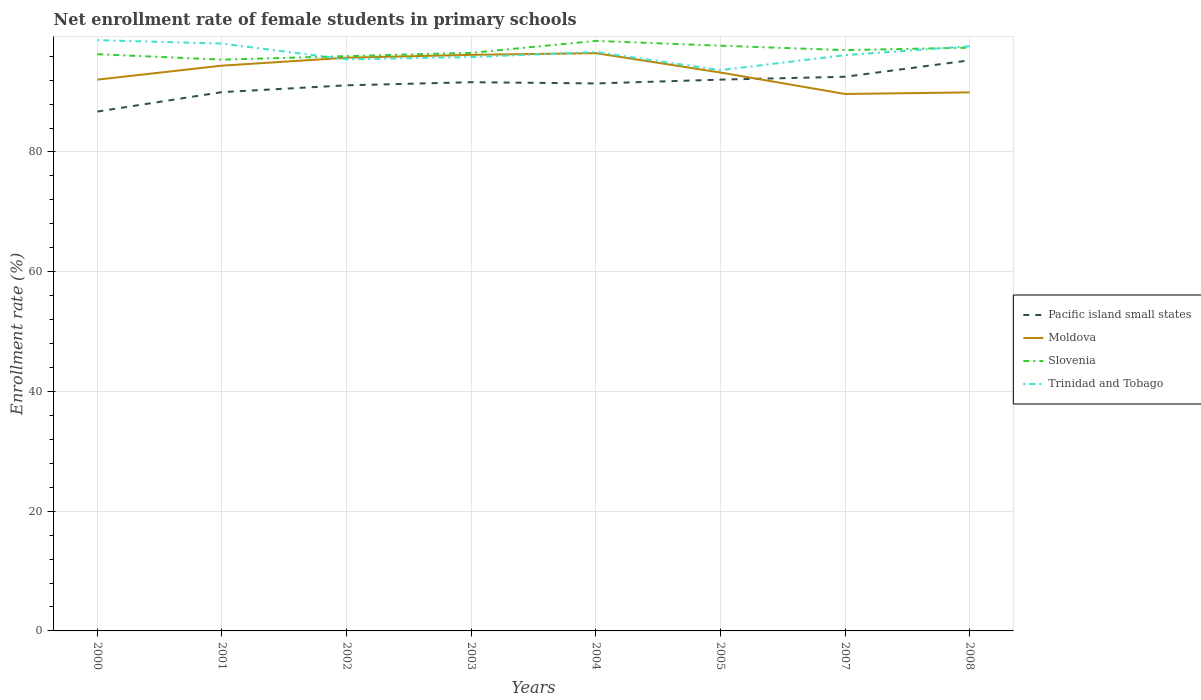How many different coloured lines are there?
Give a very brief answer. 4. Does the line corresponding to Slovenia intersect with the line corresponding to Trinidad and Tobago?
Give a very brief answer. Yes. Is the number of lines equal to the number of legend labels?
Your answer should be compact. Yes. Across all years, what is the maximum net enrollment rate of female students in primary schools in Trinidad and Tobago?
Keep it short and to the point. 93.67. In which year was the net enrollment rate of female students in primary schools in Trinidad and Tobago maximum?
Make the answer very short. 2005. What is the total net enrollment rate of female students in primary schools in Trinidad and Tobago in the graph?
Ensure brevity in your answer.  -2.19. What is the difference between the highest and the second highest net enrollment rate of female students in primary schools in Slovenia?
Offer a terse response. 3.13. What is the difference between the highest and the lowest net enrollment rate of female students in primary schools in Pacific island small states?
Your answer should be compact. 5. Is the net enrollment rate of female students in primary schools in Pacific island small states strictly greater than the net enrollment rate of female students in primary schools in Moldova over the years?
Provide a succinct answer. No. How many lines are there?
Ensure brevity in your answer.  4. How many years are there in the graph?
Ensure brevity in your answer.  8. Are the values on the major ticks of Y-axis written in scientific E-notation?
Provide a succinct answer. No. Does the graph contain any zero values?
Give a very brief answer. No. Does the graph contain grids?
Your answer should be compact. Yes. What is the title of the graph?
Provide a short and direct response. Net enrollment rate of female students in primary schools. What is the label or title of the Y-axis?
Provide a short and direct response. Enrollment rate (%). What is the Enrollment rate (%) in Pacific island small states in 2000?
Your answer should be very brief. 86.75. What is the Enrollment rate (%) of Moldova in 2000?
Offer a very short reply. 92.08. What is the Enrollment rate (%) in Slovenia in 2000?
Offer a very short reply. 96.33. What is the Enrollment rate (%) in Trinidad and Tobago in 2000?
Ensure brevity in your answer.  98.68. What is the Enrollment rate (%) in Pacific island small states in 2001?
Your answer should be compact. 90. What is the Enrollment rate (%) of Moldova in 2001?
Your answer should be compact. 94.42. What is the Enrollment rate (%) in Slovenia in 2001?
Give a very brief answer. 95.42. What is the Enrollment rate (%) in Trinidad and Tobago in 2001?
Ensure brevity in your answer.  98.1. What is the Enrollment rate (%) of Pacific island small states in 2002?
Provide a succinct answer. 91.13. What is the Enrollment rate (%) in Moldova in 2002?
Provide a succinct answer. 95.74. What is the Enrollment rate (%) in Slovenia in 2002?
Ensure brevity in your answer.  96.01. What is the Enrollment rate (%) of Trinidad and Tobago in 2002?
Offer a very short reply. 95.48. What is the Enrollment rate (%) of Pacific island small states in 2003?
Ensure brevity in your answer.  91.65. What is the Enrollment rate (%) of Moldova in 2003?
Offer a terse response. 96.23. What is the Enrollment rate (%) of Slovenia in 2003?
Give a very brief answer. 96.56. What is the Enrollment rate (%) in Trinidad and Tobago in 2003?
Your response must be concise. 95.85. What is the Enrollment rate (%) of Pacific island small states in 2004?
Offer a terse response. 91.45. What is the Enrollment rate (%) of Moldova in 2004?
Your response must be concise. 96.51. What is the Enrollment rate (%) in Slovenia in 2004?
Your answer should be very brief. 98.55. What is the Enrollment rate (%) of Trinidad and Tobago in 2004?
Keep it short and to the point. 96.7. What is the Enrollment rate (%) of Pacific island small states in 2005?
Offer a very short reply. 92.08. What is the Enrollment rate (%) of Moldova in 2005?
Provide a short and direct response. 93.27. What is the Enrollment rate (%) in Slovenia in 2005?
Your answer should be compact. 97.75. What is the Enrollment rate (%) of Trinidad and Tobago in 2005?
Your answer should be compact. 93.67. What is the Enrollment rate (%) in Pacific island small states in 2007?
Your response must be concise. 92.56. What is the Enrollment rate (%) in Moldova in 2007?
Your response must be concise. 89.69. What is the Enrollment rate (%) in Slovenia in 2007?
Your answer should be compact. 97.01. What is the Enrollment rate (%) in Trinidad and Tobago in 2007?
Provide a succinct answer. 96.17. What is the Enrollment rate (%) of Pacific island small states in 2008?
Make the answer very short. 95.31. What is the Enrollment rate (%) in Moldova in 2008?
Your response must be concise. 89.96. What is the Enrollment rate (%) of Slovenia in 2008?
Provide a succinct answer. 97.42. What is the Enrollment rate (%) in Trinidad and Tobago in 2008?
Your answer should be compact. 97.66. Across all years, what is the maximum Enrollment rate (%) of Pacific island small states?
Provide a succinct answer. 95.31. Across all years, what is the maximum Enrollment rate (%) in Moldova?
Give a very brief answer. 96.51. Across all years, what is the maximum Enrollment rate (%) in Slovenia?
Provide a short and direct response. 98.55. Across all years, what is the maximum Enrollment rate (%) in Trinidad and Tobago?
Your answer should be very brief. 98.68. Across all years, what is the minimum Enrollment rate (%) in Pacific island small states?
Give a very brief answer. 86.75. Across all years, what is the minimum Enrollment rate (%) of Moldova?
Your answer should be very brief. 89.69. Across all years, what is the minimum Enrollment rate (%) of Slovenia?
Your answer should be compact. 95.42. Across all years, what is the minimum Enrollment rate (%) in Trinidad and Tobago?
Provide a succinct answer. 93.67. What is the total Enrollment rate (%) in Pacific island small states in the graph?
Your response must be concise. 730.94. What is the total Enrollment rate (%) in Moldova in the graph?
Keep it short and to the point. 747.89. What is the total Enrollment rate (%) in Slovenia in the graph?
Keep it short and to the point. 775.06. What is the total Enrollment rate (%) of Trinidad and Tobago in the graph?
Provide a succinct answer. 772.32. What is the difference between the Enrollment rate (%) of Pacific island small states in 2000 and that in 2001?
Make the answer very short. -3.25. What is the difference between the Enrollment rate (%) in Moldova in 2000 and that in 2001?
Keep it short and to the point. -2.34. What is the difference between the Enrollment rate (%) in Slovenia in 2000 and that in 2001?
Your response must be concise. 0.91. What is the difference between the Enrollment rate (%) in Trinidad and Tobago in 2000 and that in 2001?
Keep it short and to the point. 0.58. What is the difference between the Enrollment rate (%) of Pacific island small states in 2000 and that in 2002?
Give a very brief answer. -4.38. What is the difference between the Enrollment rate (%) in Moldova in 2000 and that in 2002?
Make the answer very short. -3.66. What is the difference between the Enrollment rate (%) in Slovenia in 2000 and that in 2002?
Your answer should be compact. 0.32. What is the difference between the Enrollment rate (%) in Trinidad and Tobago in 2000 and that in 2002?
Your response must be concise. 3.2. What is the difference between the Enrollment rate (%) of Pacific island small states in 2000 and that in 2003?
Your answer should be compact. -4.9. What is the difference between the Enrollment rate (%) of Moldova in 2000 and that in 2003?
Make the answer very short. -4.14. What is the difference between the Enrollment rate (%) in Slovenia in 2000 and that in 2003?
Ensure brevity in your answer.  -0.22. What is the difference between the Enrollment rate (%) of Trinidad and Tobago in 2000 and that in 2003?
Give a very brief answer. 2.83. What is the difference between the Enrollment rate (%) of Pacific island small states in 2000 and that in 2004?
Your response must be concise. -4.7. What is the difference between the Enrollment rate (%) of Moldova in 2000 and that in 2004?
Provide a succinct answer. -4.42. What is the difference between the Enrollment rate (%) in Slovenia in 2000 and that in 2004?
Provide a short and direct response. -2.22. What is the difference between the Enrollment rate (%) in Trinidad and Tobago in 2000 and that in 2004?
Give a very brief answer. 1.98. What is the difference between the Enrollment rate (%) of Pacific island small states in 2000 and that in 2005?
Offer a terse response. -5.33. What is the difference between the Enrollment rate (%) of Moldova in 2000 and that in 2005?
Give a very brief answer. -1.19. What is the difference between the Enrollment rate (%) of Slovenia in 2000 and that in 2005?
Offer a very short reply. -1.42. What is the difference between the Enrollment rate (%) of Trinidad and Tobago in 2000 and that in 2005?
Make the answer very short. 5.01. What is the difference between the Enrollment rate (%) in Pacific island small states in 2000 and that in 2007?
Offer a very short reply. -5.81. What is the difference between the Enrollment rate (%) of Moldova in 2000 and that in 2007?
Provide a succinct answer. 2.4. What is the difference between the Enrollment rate (%) of Slovenia in 2000 and that in 2007?
Ensure brevity in your answer.  -0.68. What is the difference between the Enrollment rate (%) of Trinidad and Tobago in 2000 and that in 2007?
Your answer should be very brief. 2.51. What is the difference between the Enrollment rate (%) of Pacific island small states in 2000 and that in 2008?
Provide a succinct answer. -8.56. What is the difference between the Enrollment rate (%) in Moldova in 2000 and that in 2008?
Provide a short and direct response. 2.13. What is the difference between the Enrollment rate (%) in Slovenia in 2000 and that in 2008?
Offer a very short reply. -1.09. What is the difference between the Enrollment rate (%) in Trinidad and Tobago in 2000 and that in 2008?
Give a very brief answer. 1.02. What is the difference between the Enrollment rate (%) of Pacific island small states in 2001 and that in 2002?
Your answer should be very brief. -1.14. What is the difference between the Enrollment rate (%) of Moldova in 2001 and that in 2002?
Make the answer very short. -1.32. What is the difference between the Enrollment rate (%) in Slovenia in 2001 and that in 2002?
Offer a very short reply. -0.59. What is the difference between the Enrollment rate (%) in Trinidad and Tobago in 2001 and that in 2002?
Offer a very short reply. 2.63. What is the difference between the Enrollment rate (%) in Pacific island small states in 2001 and that in 2003?
Give a very brief answer. -1.66. What is the difference between the Enrollment rate (%) in Moldova in 2001 and that in 2003?
Provide a short and direct response. -1.81. What is the difference between the Enrollment rate (%) in Slovenia in 2001 and that in 2003?
Provide a short and direct response. -1.13. What is the difference between the Enrollment rate (%) in Trinidad and Tobago in 2001 and that in 2003?
Make the answer very short. 2.25. What is the difference between the Enrollment rate (%) in Pacific island small states in 2001 and that in 2004?
Keep it short and to the point. -1.45. What is the difference between the Enrollment rate (%) in Moldova in 2001 and that in 2004?
Your response must be concise. -2.09. What is the difference between the Enrollment rate (%) in Slovenia in 2001 and that in 2004?
Offer a terse response. -3.13. What is the difference between the Enrollment rate (%) of Trinidad and Tobago in 2001 and that in 2004?
Keep it short and to the point. 1.4. What is the difference between the Enrollment rate (%) in Pacific island small states in 2001 and that in 2005?
Ensure brevity in your answer.  -2.09. What is the difference between the Enrollment rate (%) of Moldova in 2001 and that in 2005?
Make the answer very short. 1.15. What is the difference between the Enrollment rate (%) of Slovenia in 2001 and that in 2005?
Your answer should be compact. -2.33. What is the difference between the Enrollment rate (%) in Trinidad and Tobago in 2001 and that in 2005?
Your response must be concise. 4.43. What is the difference between the Enrollment rate (%) of Pacific island small states in 2001 and that in 2007?
Your response must be concise. -2.57. What is the difference between the Enrollment rate (%) in Moldova in 2001 and that in 2007?
Provide a succinct answer. 4.73. What is the difference between the Enrollment rate (%) of Slovenia in 2001 and that in 2007?
Keep it short and to the point. -1.59. What is the difference between the Enrollment rate (%) in Trinidad and Tobago in 2001 and that in 2007?
Give a very brief answer. 1.93. What is the difference between the Enrollment rate (%) of Pacific island small states in 2001 and that in 2008?
Offer a very short reply. -5.31. What is the difference between the Enrollment rate (%) of Moldova in 2001 and that in 2008?
Keep it short and to the point. 4.46. What is the difference between the Enrollment rate (%) of Slovenia in 2001 and that in 2008?
Your answer should be compact. -2. What is the difference between the Enrollment rate (%) of Trinidad and Tobago in 2001 and that in 2008?
Make the answer very short. 0.44. What is the difference between the Enrollment rate (%) in Pacific island small states in 2002 and that in 2003?
Your answer should be compact. -0.52. What is the difference between the Enrollment rate (%) of Moldova in 2002 and that in 2003?
Your answer should be very brief. -0.48. What is the difference between the Enrollment rate (%) of Slovenia in 2002 and that in 2003?
Provide a short and direct response. -0.55. What is the difference between the Enrollment rate (%) of Trinidad and Tobago in 2002 and that in 2003?
Make the answer very short. -0.38. What is the difference between the Enrollment rate (%) in Pacific island small states in 2002 and that in 2004?
Ensure brevity in your answer.  -0.31. What is the difference between the Enrollment rate (%) of Moldova in 2002 and that in 2004?
Provide a short and direct response. -0.77. What is the difference between the Enrollment rate (%) in Slovenia in 2002 and that in 2004?
Give a very brief answer. -2.54. What is the difference between the Enrollment rate (%) in Trinidad and Tobago in 2002 and that in 2004?
Offer a terse response. -1.22. What is the difference between the Enrollment rate (%) of Pacific island small states in 2002 and that in 2005?
Offer a very short reply. -0.95. What is the difference between the Enrollment rate (%) in Moldova in 2002 and that in 2005?
Keep it short and to the point. 2.47. What is the difference between the Enrollment rate (%) of Slovenia in 2002 and that in 2005?
Provide a succinct answer. -1.74. What is the difference between the Enrollment rate (%) of Trinidad and Tobago in 2002 and that in 2005?
Offer a terse response. 1.81. What is the difference between the Enrollment rate (%) of Pacific island small states in 2002 and that in 2007?
Ensure brevity in your answer.  -1.43. What is the difference between the Enrollment rate (%) in Moldova in 2002 and that in 2007?
Offer a very short reply. 6.06. What is the difference between the Enrollment rate (%) of Slovenia in 2002 and that in 2007?
Provide a short and direct response. -1. What is the difference between the Enrollment rate (%) in Trinidad and Tobago in 2002 and that in 2007?
Your answer should be very brief. -0.7. What is the difference between the Enrollment rate (%) in Pacific island small states in 2002 and that in 2008?
Provide a succinct answer. -4.18. What is the difference between the Enrollment rate (%) of Moldova in 2002 and that in 2008?
Provide a succinct answer. 5.78. What is the difference between the Enrollment rate (%) of Slovenia in 2002 and that in 2008?
Give a very brief answer. -1.41. What is the difference between the Enrollment rate (%) of Trinidad and Tobago in 2002 and that in 2008?
Offer a terse response. -2.19. What is the difference between the Enrollment rate (%) in Pacific island small states in 2003 and that in 2004?
Provide a succinct answer. 0.21. What is the difference between the Enrollment rate (%) of Moldova in 2003 and that in 2004?
Keep it short and to the point. -0.28. What is the difference between the Enrollment rate (%) of Slovenia in 2003 and that in 2004?
Ensure brevity in your answer.  -1.99. What is the difference between the Enrollment rate (%) in Trinidad and Tobago in 2003 and that in 2004?
Provide a short and direct response. -0.85. What is the difference between the Enrollment rate (%) of Pacific island small states in 2003 and that in 2005?
Your answer should be compact. -0.43. What is the difference between the Enrollment rate (%) in Moldova in 2003 and that in 2005?
Provide a short and direct response. 2.95. What is the difference between the Enrollment rate (%) of Slovenia in 2003 and that in 2005?
Give a very brief answer. -1.19. What is the difference between the Enrollment rate (%) of Trinidad and Tobago in 2003 and that in 2005?
Offer a terse response. 2.18. What is the difference between the Enrollment rate (%) in Pacific island small states in 2003 and that in 2007?
Provide a short and direct response. -0.91. What is the difference between the Enrollment rate (%) of Moldova in 2003 and that in 2007?
Keep it short and to the point. 6.54. What is the difference between the Enrollment rate (%) of Slovenia in 2003 and that in 2007?
Ensure brevity in your answer.  -0.45. What is the difference between the Enrollment rate (%) of Trinidad and Tobago in 2003 and that in 2007?
Ensure brevity in your answer.  -0.32. What is the difference between the Enrollment rate (%) of Pacific island small states in 2003 and that in 2008?
Offer a very short reply. -3.66. What is the difference between the Enrollment rate (%) in Moldova in 2003 and that in 2008?
Your response must be concise. 6.27. What is the difference between the Enrollment rate (%) of Slovenia in 2003 and that in 2008?
Provide a succinct answer. -0.87. What is the difference between the Enrollment rate (%) of Trinidad and Tobago in 2003 and that in 2008?
Make the answer very short. -1.81. What is the difference between the Enrollment rate (%) in Pacific island small states in 2004 and that in 2005?
Your answer should be very brief. -0.64. What is the difference between the Enrollment rate (%) in Moldova in 2004 and that in 2005?
Provide a succinct answer. 3.23. What is the difference between the Enrollment rate (%) in Slovenia in 2004 and that in 2005?
Offer a very short reply. 0.8. What is the difference between the Enrollment rate (%) in Trinidad and Tobago in 2004 and that in 2005?
Provide a short and direct response. 3.03. What is the difference between the Enrollment rate (%) of Pacific island small states in 2004 and that in 2007?
Ensure brevity in your answer.  -1.12. What is the difference between the Enrollment rate (%) in Moldova in 2004 and that in 2007?
Give a very brief answer. 6.82. What is the difference between the Enrollment rate (%) of Slovenia in 2004 and that in 2007?
Your answer should be very brief. 1.54. What is the difference between the Enrollment rate (%) in Trinidad and Tobago in 2004 and that in 2007?
Ensure brevity in your answer.  0.53. What is the difference between the Enrollment rate (%) of Pacific island small states in 2004 and that in 2008?
Your answer should be very brief. -3.86. What is the difference between the Enrollment rate (%) in Moldova in 2004 and that in 2008?
Keep it short and to the point. 6.55. What is the difference between the Enrollment rate (%) of Slovenia in 2004 and that in 2008?
Provide a succinct answer. 1.13. What is the difference between the Enrollment rate (%) of Trinidad and Tobago in 2004 and that in 2008?
Offer a very short reply. -0.96. What is the difference between the Enrollment rate (%) of Pacific island small states in 2005 and that in 2007?
Provide a short and direct response. -0.48. What is the difference between the Enrollment rate (%) in Moldova in 2005 and that in 2007?
Your answer should be compact. 3.59. What is the difference between the Enrollment rate (%) of Slovenia in 2005 and that in 2007?
Your answer should be compact. 0.74. What is the difference between the Enrollment rate (%) in Trinidad and Tobago in 2005 and that in 2007?
Provide a succinct answer. -2.5. What is the difference between the Enrollment rate (%) of Pacific island small states in 2005 and that in 2008?
Offer a very short reply. -3.23. What is the difference between the Enrollment rate (%) of Moldova in 2005 and that in 2008?
Offer a terse response. 3.32. What is the difference between the Enrollment rate (%) in Slovenia in 2005 and that in 2008?
Your response must be concise. 0.33. What is the difference between the Enrollment rate (%) of Trinidad and Tobago in 2005 and that in 2008?
Provide a succinct answer. -3.99. What is the difference between the Enrollment rate (%) in Pacific island small states in 2007 and that in 2008?
Give a very brief answer. -2.75. What is the difference between the Enrollment rate (%) in Moldova in 2007 and that in 2008?
Your answer should be compact. -0.27. What is the difference between the Enrollment rate (%) in Slovenia in 2007 and that in 2008?
Give a very brief answer. -0.41. What is the difference between the Enrollment rate (%) in Trinidad and Tobago in 2007 and that in 2008?
Offer a terse response. -1.49. What is the difference between the Enrollment rate (%) in Pacific island small states in 2000 and the Enrollment rate (%) in Moldova in 2001?
Provide a succinct answer. -7.67. What is the difference between the Enrollment rate (%) of Pacific island small states in 2000 and the Enrollment rate (%) of Slovenia in 2001?
Your response must be concise. -8.67. What is the difference between the Enrollment rate (%) of Pacific island small states in 2000 and the Enrollment rate (%) of Trinidad and Tobago in 2001?
Your answer should be very brief. -11.35. What is the difference between the Enrollment rate (%) in Moldova in 2000 and the Enrollment rate (%) in Slovenia in 2001?
Your answer should be very brief. -3.34. What is the difference between the Enrollment rate (%) of Moldova in 2000 and the Enrollment rate (%) of Trinidad and Tobago in 2001?
Make the answer very short. -6.02. What is the difference between the Enrollment rate (%) of Slovenia in 2000 and the Enrollment rate (%) of Trinidad and Tobago in 2001?
Give a very brief answer. -1.77. What is the difference between the Enrollment rate (%) of Pacific island small states in 2000 and the Enrollment rate (%) of Moldova in 2002?
Make the answer very short. -8.99. What is the difference between the Enrollment rate (%) in Pacific island small states in 2000 and the Enrollment rate (%) in Slovenia in 2002?
Ensure brevity in your answer.  -9.26. What is the difference between the Enrollment rate (%) in Pacific island small states in 2000 and the Enrollment rate (%) in Trinidad and Tobago in 2002?
Offer a very short reply. -8.72. What is the difference between the Enrollment rate (%) of Moldova in 2000 and the Enrollment rate (%) of Slovenia in 2002?
Offer a very short reply. -3.93. What is the difference between the Enrollment rate (%) of Moldova in 2000 and the Enrollment rate (%) of Trinidad and Tobago in 2002?
Provide a succinct answer. -3.39. What is the difference between the Enrollment rate (%) of Slovenia in 2000 and the Enrollment rate (%) of Trinidad and Tobago in 2002?
Your response must be concise. 0.86. What is the difference between the Enrollment rate (%) of Pacific island small states in 2000 and the Enrollment rate (%) of Moldova in 2003?
Provide a short and direct response. -9.47. What is the difference between the Enrollment rate (%) of Pacific island small states in 2000 and the Enrollment rate (%) of Slovenia in 2003?
Provide a succinct answer. -9.81. What is the difference between the Enrollment rate (%) of Pacific island small states in 2000 and the Enrollment rate (%) of Trinidad and Tobago in 2003?
Provide a succinct answer. -9.1. What is the difference between the Enrollment rate (%) in Moldova in 2000 and the Enrollment rate (%) in Slovenia in 2003?
Offer a terse response. -4.47. What is the difference between the Enrollment rate (%) in Moldova in 2000 and the Enrollment rate (%) in Trinidad and Tobago in 2003?
Your response must be concise. -3.77. What is the difference between the Enrollment rate (%) in Slovenia in 2000 and the Enrollment rate (%) in Trinidad and Tobago in 2003?
Your answer should be very brief. 0.48. What is the difference between the Enrollment rate (%) in Pacific island small states in 2000 and the Enrollment rate (%) in Moldova in 2004?
Ensure brevity in your answer.  -9.76. What is the difference between the Enrollment rate (%) of Pacific island small states in 2000 and the Enrollment rate (%) of Slovenia in 2004?
Offer a very short reply. -11.8. What is the difference between the Enrollment rate (%) in Pacific island small states in 2000 and the Enrollment rate (%) in Trinidad and Tobago in 2004?
Provide a succinct answer. -9.95. What is the difference between the Enrollment rate (%) in Moldova in 2000 and the Enrollment rate (%) in Slovenia in 2004?
Provide a succinct answer. -6.47. What is the difference between the Enrollment rate (%) of Moldova in 2000 and the Enrollment rate (%) of Trinidad and Tobago in 2004?
Your answer should be compact. -4.62. What is the difference between the Enrollment rate (%) in Slovenia in 2000 and the Enrollment rate (%) in Trinidad and Tobago in 2004?
Offer a terse response. -0.37. What is the difference between the Enrollment rate (%) in Pacific island small states in 2000 and the Enrollment rate (%) in Moldova in 2005?
Give a very brief answer. -6.52. What is the difference between the Enrollment rate (%) of Pacific island small states in 2000 and the Enrollment rate (%) of Slovenia in 2005?
Offer a very short reply. -11. What is the difference between the Enrollment rate (%) of Pacific island small states in 2000 and the Enrollment rate (%) of Trinidad and Tobago in 2005?
Provide a short and direct response. -6.92. What is the difference between the Enrollment rate (%) in Moldova in 2000 and the Enrollment rate (%) in Slovenia in 2005?
Your response must be concise. -5.67. What is the difference between the Enrollment rate (%) of Moldova in 2000 and the Enrollment rate (%) of Trinidad and Tobago in 2005?
Offer a very short reply. -1.59. What is the difference between the Enrollment rate (%) of Slovenia in 2000 and the Enrollment rate (%) of Trinidad and Tobago in 2005?
Your answer should be compact. 2.66. What is the difference between the Enrollment rate (%) of Pacific island small states in 2000 and the Enrollment rate (%) of Moldova in 2007?
Offer a very short reply. -2.93. What is the difference between the Enrollment rate (%) of Pacific island small states in 2000 and the Enrollment rate (%) of Slovenia in 2007?
Keep it short and to the point. -10.26. What is the difference between the Enrollment rate (%) of Pacific island small states in 2000 and the Enrollment rate (%) of Trinidad and Tobago in 2007?
Ensure brevity in your answer.  -9.42. What is the difference between the Enrollment rate (%) in Moldova in 2000 and the Enrollment rate (%) in Slovenia in 2007?
Make the answer very short. -4.93. What is the difference between the Enrollment rate (%) in Moldova in 2000 and the Enrollment rate (%) in Trinidad and Tobago in 2007?
Your answer should be very brief. -4.09. What is the difference between the Enrollment rate (%) in Slovenia in 2000 and the Enrollment rate (%) in Trinidad and Tobago in 2007?
Make the answer very short. 0.16. What is the difference between the Enrollment rate (%) of Pacific island small states in 2000 and the Enrollment rate (%) of Moldova in 2008?
Keep it short and to the point. -3.21. What is the difference between the Enrollment rate (%) in Pacific island small states in 2000 and the Enrollment rate (%) in Slovenia in 2008?
Provide a short and direct response. -10.67. What is the difference between the Enrollment rate (%) in Pacific island small states in 2000 and the Enrollment rate (%) in Trinidad and Tobago in 2008?
Offer a terse response. -10.91. What is the difference between the Enrollment rate (%) of Moldova in 2000 and the Enrollment rate (%) of Slovenia in 2008?
Your answer should be compact. -5.34. What is the difference between the Enrollment rate (%) of Moldova in 2000 and the Enrollment rate (%) of Trinidad and Tobago in 2008?
Your response must be concise. -5.58. What is the difference between the Enrollment rate (%) of Slovenia in 2000 and the Enrollment rate (%) of Trinidad and Tobago in 2008?
Make the answer very short. -1.33. What is the difference between the Enrollment rate (%) in Pacific island small states in 2001 and the Enrollment rate (%) in Moldova in 2002?
Keep it short and to the point. -5.74. What is the difference between the Enrollment rate (%) of Pacific island small states in 2001 and the Enrollment rate (%) of Slovenia in 2002?
Your answer should be compact. -6.01. What is the difference between the Enrollment rate (%) of Pacific island small states in 2001 and the Enrollment rate (%) of Trinidad and Tobago in 2002?
Offer a terse response. -5.48. What is the difference between the Enrollment rate (%) of Moldova in 2001 and the Enrollment rate (%) of Slovenia in 2002?
Give a very brief answer. -1.59. What is the difference between the Enrollment rate (%) of Moldova in 2001 and the Enrollment rate (%) of Trinidad and Tobago in 2002?
Offer a very short reply. -1.06. What is the difference between the Enrollment rate (%) of Slovenia in 2001 and the Enrollment rate (%) of Trinidad and Tobago in 2002?
Your answer should be very brief. -0.05. What is the difference between the Enrollment rate (%) of Pacific island small states in 2001 and the Enrollment rate (%) of Moldova in 2003?
Your response must be concise. -6.23. What is the difference between the Enrollment rate (%) in Pacific island small states in 2001 and the Enrollment rate (%) in Slovenia in 2003?
Your answer should be compact. -6.56. What is the difference between the Enrollment rate (%) of Pacific island small states in 2001 and the Enrollment rate (%) of Trinidad and Tobago in 2003?
Offer a terse response. -5.86. What is the difference between the Enrollment rate (%) of Moldova in 2001 and the Enrollment rate (%) of Slovenia in 2003?
Ensure brevity in your answer.  -2.14. What is the difference between the Enrollment rate (%) of Moldova in 2001 and the Enrollment rate (%) of Trinidad and Tobago in 2003?
Your answer should be very brief. -1.43. What is the difference between the Enrollment rate (%) of Slovenia in 2001 and the Enrollment rate (%) of Trinidad and Tobago in 2003?
Your answer should be very brief. -0.43. What is the difference between the Enrollment rate (%) in Pacific island small states in 2001 and the Enrollment rate (%) in Moldova in 2004?
Offer a very short reply. -6.51. What is the difference between the Enrollment rate (%) of Pacific island small states in 2001 and the Enrollment rate (%) of Slovenia in 2004?
Your response must be concise. -8.55. What is the difference between the Enrollment rate (%) in Pacific island small states in 2001 and the Enrollment rate (%) in Trinidad and Tobago in 2004?
Ensure brevity in your answer.  -6.7. What is the difference between the Enrollment rate (%) of Moldova in 2001 and the Enrollment rate (%) of Slovenia in 2004?
Ensure brevity in your answer.  -4.13. What is the difference between the Enrollment rate (%) of Moldova in 2001 and the Enrollment rate (%) of Trinidad and Tobago in 2004?
Provide a short and direct response. -2.28. What is the difference between the Enrollment rate (%) of Slovenia in 2001 and the Enrollment rate (%) of Trinidad and Tobago in 2004?
Provide a short and direct response. -1.28. What is the difference between the Enrollment rate (%) in Pacific island small states in 2001 and the Enrollment rate (%) in Moldova in 2005?
Your answer should be very brief. -3.28. What is the difference between the Enrollment rate (%) in Pacific island small states in 2001 and the Enrollment rate (%) in Slovenia in 2005?
Offer a very short reply. -7.75. What is the difference between the Enrollment rate (%) of Pacific island small states in 2001 and the Enrollment rate (%) of Trinidad and Tobago in 2005?
Keep it short and to the point. -3.67. What is the difference between the Enrollment rate (%) in Moldova in 2001 and the Enrollment rate (%) in Slovenia in 2005?
Give a very brief answer. -3.33. What is the difference between the Enrollment rate (%) of Moldova in 2001 and the Enrollment rate (%) of Trinidad and Tobago in 2005?
Give a very brief answer. 0.75. What is the difference between the Enrollment rate (%) in Slovenia in 2001 and the Enrollment rate (%) in Trinidad and Tobago in 2005?
Offer a terse response. 1.75. What is the difference between the Enrollment rate (%) in Pacific island small states in 2001 and the Enrollment rate (%) in Moldova in 2007?
Keep it short and to the point. 0.31. What is the difference between the Enrollment rate (%) in Pacific island small states in 2001 and the Enrollment rate (%) in Slovenia in 2007?
Your response must be concise. -7.01. What is the difference between the Enrollment rate (%) of Pacific island small states in 2001 and the Enrollment rate (%) of Trinidad and Tobago in 2007?
Your answer should be compact. -6.18. What is the difference between the Enrollment rate (%) in Moldova in 2001 and the Enrollment rate (%) in Slovenia in 2007?
Offer a terse response. -2.59. What is the difference between the Enrollment rate (%) of Moldova in 2001 and the Enrollment rate (%) of Trinidad and Tobago in 2007?
Offer a terse response. -1.75. What is the difference between the Enrollment rate (%) of Slovenia in 2001 and the Enrollment rate (%) of Trinidad and Tobago in 2007?
Your answer should be very brief. -0.75. What is the difference between the Enrollment rate (%) in Pacific island small states in 2001 and the Enrollment rate (%) in Moldova in 2008?
Provide a succinct answer. 0.04. What is the difference between the Enrollment rate (%) of Pacific island small states in 2001 and the Enrollment rate (%) of Slovenia in 2008?
Provide a succinct answer. -7.43. What is the difference between the Enrollment rate (%) in Pacific island small states in 2001 and the Enrollment rate (%) in Trinidad and Tobago in 2008?
Ensure brevity in your answer.  -7.66. What is the difference between the Enrollment rate (%) of Moldova in 2001 and the Enrollment rate (%) of Slovenia in 2008?
Keep it short and to the point. -3. What is the difference between the Enrollment rate (%) in Moldova in 2001 and the Enrollment rate (%) in Trinidad and Tobago in 2008?
Keep it short and to the point. -3.24. What is the difference between the Enrollment rate (%) in Slovenia in 2001 and the Enrollment rate (%) in Trinidad and Tobago in 2008?
Give a very brief answer. -2.24. What is the difference between the Enrollment rate (%) in Pacific island small states in 2002 and the Enrollment rate (%) in Moldova in 2003?
Ensure brevity in your answer.  -5.09. What is the difference between the Enrollment rate (%) of Pacific island small states in 2002 and the Enrollment rate (%) of Slovenia in 2003?
Offer a very short reply. -5.42. What is the difference between the Enrollment rate (%) in Pacific island small states in 2002 and the Enrollment rate (%) in Trinidad and Tobago in 2003?
Ensure brevity in your answer.  -4.72. What is the difference between the Enrollment rate (%) in Moldova in 2002 and the Enrollment rate (%) in Slovenia in 2003?
Give a very brief answer. -0.82. What is the difference between the Enrollment rate (%) in Moldova in 2002 and the Enrollment rate (%) in Trinidad and Tobago in 2003?
Your response must be concise. -0.11. What is the difference between the Enrollment rate (%) in Slovenia in 2002 and the Enrollment rate (%) in Trinidad and Tobago in 2003?
Keep it short and to the point. 0.16. What is the difference between the Enrollment rate (%) in Pacific island small states in 2002 and the Enrollment rate (%) in Moldova in 2004?
Your answer should be very brief. -5.37. What is the difference between the Enrollment rate (%) in Pacific island small states in 2002 and the Enrollment rate (%) in Slovenia in 2004?
Offer a very short reply. -7.42. What is the difference between the Enrollment rate (%) in Pacific island small states in 2002 and the Enrollment rate (%) in Trinidad and Tobago in 2004?
Make the answer very short. -5.57. What is the difference between the Enrollment rate (%) in Moldova in 2002 and the Enrollment rate (%) in Slovenia in 2004?
Offer a terse response. -2.81. What is the difference between the Enrollment rate (%) in Moldova in 2002 and the Enrollment rate (%) in Trinidad and Tobago in 2004?
Provide a succinct answer. -0.96. What is the difference between the Enrollment rate (%) in Slovenia in 2002 and the Enrollment rate (%) in Trinidad and Tobago in 2004?
Offer a terse response. -0.69. What is the difference between the Enrollment rate (%) of Pacific island small states in 2002 and the Enrollment rate (%) of Moldova in 2005?
Ensure brevity in your answer.  -2.14. What is the difference between the Enrollment rate (%) in Pacific island small states in 2002 and the Enrollment rate (%) in Slovenia in 2005?
Provide a succinct answer. -6.62. What is the difference between the Enrollment rate (%) of Pacific island small states in 2002 and the Enrollment rate (%) of Trinidad and Tobago in 2005?
Give a very brief answer. -2.54. What is the difference between the Enrollment rate (%) in Moldova in 2002 and the Enrollment rate (%) in Slovenia in 2005?
Offer a very short reply. -2.01. What is the difference between the Enrollment rate (%) in Moldova in 2002 and the Enrollment rate (%) in Trinidad and Tobago in 2005?
Give a very brief answer. 2.07. What is the difference between the Enrollment rate (%) of Slovenia in 2002 and the Enrollment rate (%) of Trinidad and Tobago in 2005?
Give a very brief answer. 2.34. What is the difference between the Enrollment rate (%) in Pacific island small states in 2002 and the Enrollment rate (%) in Moldova in 2007?
Provide a short and direct response. 1.45. What is the difference between the Enrollment rate (%) in Pacific island small states in 2002 and the Enrollment rate (%) in Slovenia in 2007?
Provide a succinct answer. -5.88. What is the difference between the Enrollment rate (%) in Pacific island small states in 2002 and the Enrollment rate (%) in Trinidad and Tobago in 2007?
Your answer should be compact. -5.04. What is the difference between the Enrollment rate (%) in Moldova in 2002 and the Enrollment rate (%) in Slovenia in 2007?
Ensure brevity in your answer.  -1.27. What is the difference between the Enrollment rate (%) in Moldova in 2002 and the Enrollment rate (%) in Trinidad and Tobago in 2007?
Provide a short and direct response. -0.43. What is the difference between the Enrollment rate (%) of Slovenia in 2002 and the Enrollment rate (%) of Trinidad and Tobago in 2007?
Your answer should be compact. -0.16. What is the difference between the Enrollment rate (%) in Pacific island small states in 2002 and the Enrollment rate (%) in Moldova in 2008?
Keep it short and to the point. 1.18. What is the difference between the Enrollment rate (%) of Pacific island small states in 2002 and the Enrollment rate (%) of Slovenia in 2008?
Provide a short and direct response. -6.29. What is the difference between the Enrollment rate (%) in Pacific island small states in 2002 and the Enrollment rate (%) in Trinidad and Tobago in 2008?
Provide a succinct answer. -6.53. What is the difference between the Enrollment rate (%) of Moldova in 2002 and the Enrollment rate (%) of Slovenia in 2008?
Keep it short and to the point. -1.68. What is the difference between the Enrollment rate (%) of Moldova in 2002 and the Enrollment rate (%) of Trinidad and Tobago in 2008?
Make the answer very short. -1.92. What is the difference between the Enrollment rate (%) in Slovenia in 2002 and the Enrollment rate (%) in Trinidad and Tobago in 2008?
Offer a very short reply. -1.65. What is the difference between the Enrollment rate (%) of Pacific island small states in 2003 and the Enrollment rate (%) of Moldova in 2004?
Keep it short and to the point. -4.85. What is the difference between the Enrollment rate (%) in Pacific island small states in 2003 and the Enrollment rate (%) in Slovenia in 2004?
Your response must be concise. -6.9. What is the difference between the Enrollment rate (%) in Pacific island small states in 2003 and the Enrollment rate (%) in Trinidad and Tobago in 2004?
Provide a short and direct response. -5.05. What is the difference between the Enrollment rate (%) in Moldova in 2003 and the Enrollment rate (%) in Slovenia in 2004?
Make the answer very short. -2.33. What is the difference between the Enrollment rate (%) of Moldova in 2003 and the Enrollment rate (%) of Trinidad and Tobago in 2004?
Your answer should be very brief. -0.47. What is the difference between the Enrollment rate (%) in Slovenia in 2003 and the Enrollment rate (%) in Trinidad and Tobago in 2004?
Keep it short and to the point. -0.14. What is the difference between the Enrollment rate (%) in Pacific island small states in 2003 and the Enrollment rate (%) in Moldova in 2005?
Offer a very short reply. -1.62. What is the difference between the Enrollment rate (%) in Pacific island small states in 2003 and the Enrollment rate (%) in Slovenia in 2005?
Make the answer very short. -6.1. What is the difference between the Enrollment rate (%) in Pacific island small states in 2003 and the Enrollment rate (%) in Trinidad and Tobago in 2005?
Provide a succinct answer. -2.02. What is the difference between the Enrollment rate (%) of Moldova in 2003 and the Enrollment rate (%) of Slovenia in 2005?
Offer a very short reply. -1.53. What is the difference between the Enrollment rate (%) of Moldova in 2003 and the Enrollment rate (%) of Trinidad and Tobago in 2005?
Your answer should be very brief. 2.56. What is the difference between the Enrollment rate (%) in Slovenia in 2003 and the Enrollment rate (%) in Trinidad and Tobago in 2005?
Your answer should be compact. 2.89. What is the difference between the Enrollment rate (%) in Pacific island small states in 2003 and the Enrollment rate (%) in Moldova in 2007?
Offer a terse response. 1.97. What is the difference between the Enrollment rate (%) of Pacific island small states in 2003 and the Enrollment rate (%) of Slovenia in 2007?
Your response must be concise. -5.36. What is the difference between the Enrollment rate (%) of Pacific island small states in 2003 and the Enrollment rate (%) of Trinidad and Tobago in 2007?
Give a very brief answer. -4.52. What is the difference between the Enrollment rate (%) in Moldova in 2003 and the Enrollment rate (%) in Slovenia in 2007?
Provide a succinct answer. -0.79. What is the difference between the Enrollment rate (%) in Moldova in 2003 and the Enrollment rate (%) in Trinidad and Tobago in 2007?
Your response must be concise. 0.05. What is the difference between the Enrollment rate (%) of Slovenia in 2003 and the Enrollment rate (%) of Trinidad and Tobago in 2007?
Give a very brief answer. 0.38. What is the difference between the Enrollment rate (%) in Pacific island small states in 2003 and the Enrollment rate (%) in Moldova in 2008?
Keep it short and to the point. 1.7. What is the difference between the Enrollment rate (%) in Pacific island small states in 2003 and the Enrollment rate (%) in Slovenia in 2008?
Make the answer very short. -5.77. What is the difference between the Enrollment rate (%) of Pacific island small states in 2003 and the Enrollment rate (%) of Trinidad and Tobago in 2008?
Make the answer very short. -6.01. What is the difference between the Enrollment rate (%) of Moldova in 2003 and the Enrollment rate (%) of Slovenia in 2008?
Give a very brief answer. -1.2. What is the difference between the Enrollment rate (%) in Moldova in 2003 and the Enrollment rate (%) in Trinidad and Tobago in 2008?
Provide a short and direct response. -1.44. What is the difference between the Enrollment rate (%) in Slovenia in 2003 and the Enrollment rate (%) in Trinidad and Tobago in 2008?
Ensure brevity in your answer.  -1.1. What is the difference between the Enrollment rate (%) in Pacific island small states in 2004 and the Enrollment rate (%) in Moldova in 2005?
Offer a very short reply. -1.83. What is the difference between the Enrollment rate (%) of Pacific island small states in 2004 and the Enrollment rate (%) of Slovenia in 2005?
Offer a terse response. -6.3. What is the difference between the Enrollment rate (%) of Pacific island small states in 2004 and the Enrollment rate (%) of Trinidad and Tobago in 2005?
Give a very brief answer. -2.22. What is the difference between the Enrollment rate (%) in Moldova in 2004 and the Enrollment rate (%) in Slovenia in 2005?
Your answer should be very brief. -1.24. What is the difference between the Enrollment rate (%) in Moldova in 2004 and the Enrollment rate (%) in Trinidad and Tobago in 2005?
Make the answer very short. 2.84. What is the difference between the Enrollment rate (%) in Slovenia in 2004 and the Enrollment rate (%) in Trinidad and Tobago in 2005?
Offer a very short reply. 4.88. What is the difference between the Enrollment rate (%) of Pacific island small states in 2004 and the Enrollment rate (%) of Moldova in 2007?
Provide a succinct answer. 1.76. What is the difference between the Enrollment rate (%) of Pacific island small states in 2004 and the Enrollment rate (%) of Slovenia in 2007?
Offer a very short reply. -5.56. What is the difference between the Enrollment rate (%) in Pacific island small states in 2004 and the Enrollment rate (%) in Trinidad and Tobago in 2007?
Your answer should be compact. -4.73. What is the difference between the Enrollment rate (%) in Moldova in 2004 and the Enrollment rate (%) in Slovenia in 2007?
Offer a very short reply. -0.5. What is the difference between the Enrollment rate (%) in Moldova in 2004 and the Enrollment rate (%) in Trinidad and Tobago in 2007?
Offer a very short reply. 0.33. What is the difference between the Enrollment rate (%) of Slovenia in 2004 and the Enrollment rate (%) of Trinidad and Tobago in 2007?
Keep it short and to the point. 2.38. What is the difference between the Enrollment rate (%) of Pacific island small states in 2004 and the Enrollment rate (%) of Moldova in 2008?
Give a very brief answer. 1.49. What is the difference between the Enrollment rate (%) of Pacific island small states in 2004 and the Enrollment rate (%) of Slovenia in 2008?
Make the answer very short. -5.98. What is the difference between the Enrollment rate (%) in Pacific island small states in 2004 and the Enrollment rate (%) in Trinidad and Tobago in 2008?
Make the answer very short. -6.22. What is the difference between the Enrollment rate (%) in Moldova in 2004 and the Enrollment rate (%) in Slovenia in 2008?
Offer a terse response. -0.92. What is the difference between the Enrollment rate (%) of Moldova in 2004 and the Enrollment rate (%) of Trinidad and Tobago in 2008?
Provide a short and direct response. -1.15. What is the difference between the Enrollment rate (%) in Slovenia in 2004 and the Enrollment rate (%) in Trinidad and Tobago in 2008?
Ensure brevity in your answer.  0.89. What is the difference between the Enrollment rate (%) in Pacific island small states in 2005 and the Enrollment rate (%) in Moldova in 2007?
Your response must be concise. 2.4. What is the difference between the Enrollment rate (%) in Pacific island small states in 2005 and the Enrollment rate (%) in Slovenia in 2007?
Keep it short and to the point. -4.93. What is the difference between the Enrollment rate (%) in Pacific island small states in 2005 and the Enrollment rate (%) in Trinidad and Tobago in 2007?
Provide a short and direct response. -4.09. What is the difference between the Enrollment rate (%) of Moldova in 2005 and the Enrollment rate (%) of Slovenia in 2007?
Give a very brief answer. -3.74. What is the difference between the Enrollment rate (%) of Moldova in 2005 and the Enrollment rate (%) of Trinidad and Tobago in 2007?
Your answer should be compact. -2.9. What is the difference between the Enrollment rate (%) of Slovenia in 2005 and the Enrollment rate (%) of Trinidad and Tobago in 2007?
Make the answer very short. 1.58. What is the difference between the Enrollment rate (%) of Pacific island small states in 2005 and the Enrollment rate (%) of Moldova in 2008?
Offer a very short reply. 2.13. What is the difference between the Enrollment rate (%) in Pacific island small states in 2005 and the Enrollment rate (%) in Slovenia in 2008?
Your answer should be very brief. -5.34. What is the difference between the Enrollment rate (%) in Pacific island small states in 2005 and the Enrollment rate (%) in Trinidad and Tobago in 2008?
Ensure brevity in your answer.  -5.58. What is the difference between the Enrollment rate (%) of Moldova in 2005 and the Enrollment rate (%) of Slovenia in 2008?
Offer a terse response. -4.15. What is the difference between the Enrollment rate (%) in Moldova in 2005 and the Enrollment rate (%) in Trinidad and Tobago in 2008?
Make the answer very short. -4.39. What is the difference between the Enrollment rate (%) in Slovenia in 2005 and the Enrollment rate (%) in Trinidad and Tobago in 2008?
Ensure brevity in your answer.  0.09. What is the difference between the Enrollment rate (%) in Pacific island small states in 2007 and the Enrollment rate (%) in Moldova in 2008?
Offer a terse response. 2.61. What is the difference between the Enrollment rate (%) in Pacific island small states in 2007 and the Enrollment rate (%) in Slovenia in 2008?
Provide a succinct answer. -4.86. What is the difference between the Enrollment rate (%) of Pacific island small states in 2007 and the Enrollment rate (%) of Trinidad and Tobago in 2008?
Make the answer very short. -5.1. What is the difference between the Enrollment rate (%) of Moldova in 2007 and the Enrollment rate (%) of Slovenia in 2008?
Your answer should be compact. -7.74. What is the difference between the Enrollment rate (%) in Moldova in 2007 and the Enrollment rate (%) in Trinidad and Tobago in 2008?
Provide a succinct answer. -7.98. What is the difference between the Enrollment rate (%) in Slovenia in 2007 and the Enrollment rate (%) in Trinidad and Tobago in 2008?
Ensure brevity in your answer.  -0.65. What is the average Enrollment rate (%) in Pacific island small states per year?
Make the answer very short. 91.37. What is the average Enrollment rate (%) in Moldova per year?
Ensure brevity in your answer.  93.49. What is the average Enrollment rate (%) in Slovenia per year?
Keep it short and to the point. 96.88. What is the average Enrollment rate (%) in Trinidad and Tobago per year?
Make the answer very short. 96.54. In the year 2000, what is the difference between the Enrollment rate (%) in Pacific island small states and Enrollment rate (%) in Moldova?
Provide a short and direct response. -5.33. In the year 2000, what is the difference between the Enrollment rate (%) in Pacific island small states and Enrollment rate (%) in Slovenia?
Give a very brief answer. -9.58. In the year 2000, what is the difference between the Enrollment rate (%) in Pacific island small states and Enrollment rate (%) in Trinidad and Tobago?
Your answer should be compact. -11.93. In the year 2000, what is the difference between the Enrollment rate (%) of Moldova and Enrollment rate (%) of Slovenia?
Give a very brief answer. -4.25. In the year 2000, what is the difference between the Enrollment rate (%) in Moldova and Enrollment rate (%) in Trinidad and Tobago?
Ensure brevity in your answer.  -6.6. In the year 2000, what is the difference between the Enrollment rate (%) of Slovenia and Enrollment rate (%) of Trinidad and Tobago?
Keep it short and to the point. -2.35. In the year 2001, what is the difference between the Enrollment rate (%) in Pacific island small states and Enrollment rate (%) in Moldova?
Provide a succinct answer. -4.42. In the year 2001, what is the difference between the Enrollment rate (%) in Pacific island small states and Enrollment rate (%) in Slovenia?
Make the answer very short. -5.43. In the year 2001, what is the difference between the Enrollment rate (%) of Pacific island small states and Enrollment rate (%) of Trinidad and Tobago?
Offer a very short reply. -8.11. In the year 2001, what is the difference between the Enrollment rate (%) of Moldova and Enrollment rate (%) of Slovenia?
Your response must be concise. -1. In the year 2001, what is the difference between the Enrollment rate (%) of Moldova and Enrollment rate (%) of Trinidad and Tobago?
Offer a terse response. -3.68. In the year 2001, what is the difference between the Enrollment rate (%) in Slovenia and Enrollment rate (%) in Trinidad and Tobago?
Offer a very short reply. -2.68. In the year 2002, what is the difference between the Enrollment rate (%) of Pacific island small states and Enrollment rate (%) of Moldova?
Offer a very short reply. -4.61. In the year 2002, what is the difference between the Enrollment rate (%) in Pacific island small states and Enrollment rate (%) in Slovenia?
Offer a terse response. -4.88. In the year 2002, what is the difference between the Enrollment rate (%) in Pacific island small states and Enrollment rate (%) in Trinidad and Tobago?
Your answer should be compact. -4.34. In the year 2002, what is the difference between the Enrollment rate (%) of Moldova and Enrollment rate (%) of Slovenia?
Make the answer very short. -0.27. In the year 2002, what is the difference between the Enrollment rate (%) in Moldova and Enrollment rate (%) in Trinidad and Tobago?
Ensure brevity in your answer.  0.26. In the year 2002, what is the difference between the Enrollment rate (%) of Slovenia and Enrollment rate (%) of Trinidad and Tobago?
Give a very brief answer. 0.53. In the year 2003, what is the difference between the Enrollment rate (%) in Pacific island small states and Enrollment rate (%) in Moldova?
Ensure brevity in your answer.  -4.57. In the year 2003, what is the difference between the Enrollment rate (%) of Pacific island small states and Enrollment rate (%) of Slovenia?
Provide a succinct answer. -4.9. In the year 2003, what is the difference between the Enrollment rate (%) in Pacific island small states and Enrollment rate (%) in Trinidad and Tobago?
Your response must be concise. -4.2. In the year 2003, what is the difference between the Enrollment rate (%) of Moldova and Enrollment rate (%) of Slovenia?
Your answer should be very brief. -0.33. In the year 2003, what is the difference between the Enrollment rate (%) of Moldova and Enrollment rate (%) of Trinidad and Tobago?
Your answer should be very brief. 0.37. In the year 2003, what is the difference between the Enrollment rate (%) of Slovenia and Enrollment rate (%) of Trinidad and Tobago?
Your answer should be very brief. 0.7. In the year 2004, what is the difference between the Enrollment rate (%) of Pacific island small states and Enrollment rate (%) of Moldova?
Your answer should be very brief. -5.06. In the year 2004, what is the difference between the Enrollment rate (%) in Pacific island small states and Enrollment rate (%) in Slovenia?
Your answer should be very brief. -7.11. In the year 2004, what is the difference between the Enrollment rate (%) in Pacific island small states and Enrollment rate (%) in Trinidad and Tobago?
Offer a very short reply. -5.25. In the year 2004, what is the difference between the Enrollment rate (%) of Moldova and Enrollment rate (%) of Slovenia?
Provide a short and direct response. -2.04. In the year 2004, what is the difference between the Enrollment rate (%) of Moldova and Enrollment rate (%) of Trinidad and Tobago?
Your response must be concise. -0.19. In the year 2004, what is the difference between the Enrollment rate (%) in Slovenia and Enrollment rate (%) in Trinidad and Tobago?
Your response must be concise. 1.85. In the year 2005, what is the difference between the Enrollment rate (%) in Pacific island small states and Enrollment rate (%) in Moldova?
Provide a succinct answer. -1.19. In the year 2005, what is the difference between the Enrollment rate (%) of Pacific island small states and Enrollment rate (%) of Slovenia?
Provide a short and direct response. -5.67. In the year 2005, what is the difference between the Enrollment rate (%) in Pacific island small states and Enrollment rate (%) in Trinidad and Tobago?
Provide a succinct answer. -1.59. In the year 2005, what is the difference between the Enrollment rate (%) in Moldova and Enrollment rate (%) in Slovenia?
Provide a short and direct response. -4.48. In the year 2005, what is the difference between the Enrollment rate (%) of Moldova and Enrollment rate (%) of Trinidad and Tobago?
Keep it short and to the point. -0.4. In the year 2005, what is the difference between the Enrollment rate (%) of Slovenia and Enrollment rate (%) of Trinidad and Tobago?
Offer a terse response. 4.08. In the year 2007, what is the difference between the Enrollment rate (%) of Pacific island small states and Enrollment rate (%) of Moldova?
Your answer should be compact. 2.88. In the year 2007, what is the difference between the Enrollment rate (%) in Pacific island small states and Enrollment rate (%) in Slovenia?
Your answer should be very brief. -4.45. In the year 2007, what is the difference between the Enrollment rate (%) of Pacific island small states and Enrollment rate (%) of Trinidad and Tobago?
Provide a succinct answer. -3.61. In the year 2007, what is the difference between the Enrollment rate (%) of Moldova and Enrollment rate (%) of Slovenia?
Provide a short and direct response. -7.33. In the year 2007, what is the difference between the Enrollment rate (%) of Moldova and Enrollment rate (%) of Trinidad and Tobago?
Provide a short and direct response. -6.49. In the year 2007, what is the difference between the Enrollment rate (%) of Slovenia and Enrollment rate (%) of Trinidad and Tobago?
Provide a succinct answer. 0.84. In the year 2008, what is the difference between the Enrollment rate (%) of Pacific island small states and Enrollment rate (%) of Moldova?
Your response must be concise. 5.35. In the year 2008, what is the difference between the Enrollment rate (%) of Pacific island small states and Enrollment rate (%) of Slovenia?
Offer a terse response. -2.11. In the year 2008, what is the difference between the Enrollment rate (%) of Pacific island small states and Enrollment rate (%) of Trinidad and Tobago?
Offer a very short reply. -2.35. In the year 2008, what is the difference between the Enrollment rate (%) in Moldova and Enrollment rate (%) in Slovenia?
Keep it short and to the point. -7.47. In the year 2008, what is the difference between the Enrollment rate (%) in Moldova and Enrollment rate (%) in Trinidad and Tobago?
Provide a short and direct response. -7.71. In the year 2008, what is the difference between the Enrollment rate (%) in Slovenia and Enrollment rate (%) in Trinidad and Tobago?
Provide a succinct answer. -0.24. What is the ratio of the Enrollment rate (%) in Pacific island small states in 2000 to that in 2001?
Your answer should be very brief. 0.96. What is the ratio of the Enrollment rate (%) in Moldova in 2000 to that in 2001?
Offer a very short reply. 0.98. What is the ratio of the Enrollment rate (%) of Slovenia in 2000 to that in 2001?
Offer a very short reply. 1.01. What is the ratio of the Enrollment rate (%) in Trinidad and Tobago in 2000 to that in 2001?
Provide a short and direct response. 1.01. What is the ratio of the Enrollment rate (%) of Pacific island small states in 2000 to that in 2002?
Provide a short and direct response. 0.95. What is the ratio of the Enrollment rate (%) in Moldova in 2000 to that in 2002?
Your response must be concise. 0.96. What is the ratio of the Enrollment rate (%) of Slovenia in 2000 to that in 2002?
Your response must be concise. 1. What is the ratio of the Enrollment rate (%) of Trinidad and Tobago in 2000 to that in 2002?
Ensure brevity in your answer.  1.03. What is the ratio of the Enrollment rate (%) of Pacific island small states in 2000 to that in 2003?
Offer a terse response. 0.95. What is the ratio of the Enrollment rate (%) of Moldova in 2000 to that in 2003?
Your answer should be compact. 0.96. What is the ratio of the Enrollment rate (%) in Trinidad and Tobago in 2000 to that in 2003?
Provide a short and direct response. 1.03. What is the ratio of the Enrollment rate (%) in Pacific island small states in 2000 to that in 2004?
Offer a terse response. 0.95. What is the ratio of the Enrollment rate (%) in Moldova in 2000 to that in 2004?
Keep it short and to the point. 0.95. What is the ratio of the Enrollment rate (%) of Slovenia in 2000 to that in 2004?
Make the answer very short. 0.98. What is the ratio of the Enrollment rate (%) of Trinidad and Tobago in 2000 to that in 2004?
Provide a short and direct response. 1.02. What is the ratio of the Enrollment rate (%) of Pacific island small states in 2000 to that in 2005?
Keep it short and to the point. 0.94. What is the ratio of the Enrollment rate (%) of Moldova in 2000 to that in 2005?
Your answer should be compact. 0.99. What is the ratio of the Enrollment rate (%) of Slovenia in 2000 to that in 2005?
Your answer should be compact. 0.99. What is the ratio of the Enrollment rate (%) of Trinidad and Tobago in 2000 to that in 2005?
Offer a very short reply. 1.05. What is the ratio of the Enrollment rate (%) of Pacific island small states in 2000 to that in 2007?
Your response must be concise. 0.94. What is the ratio of the Enrollment rate (%) of Moldova in 2000 to that in 2007?
Offer a very short reply. 1.03. What is the ratio of the Enrollment rate (%) in Slovenia in 2000 to that in 2007?
Give a very brief answer. 0.99. What is the ratio of the Enrollment rate (%) of Trinidad and Tobago in 2000 to that in 2007?
Keep it short and to the point. 1.03. What is the ratio of the Enrollment rate (%) in Pacific island small states in 2000 to that in 2008?
Keep it short and to the point. 0.91. What is the ratio of the Enrollment rate (%) of Moldova in 2000 to that in 2008?
Give a very brief answer. 1.02. What is the ratio of the Enrollment rate (%) of Trinidad and Tobago in 2000 to that in 2008?
Ensure brevity in your answer.  1.01. What is the ratio of the Enrollment rate (%) in Pacific island small states in 2001 to that in 2002?
Your answer should be very brief. 0.99. What is the ratio of the Enrollment rate (%) in Moldova in 2001 to that in 2002?
Give a very brief answer. 0.99. What is the ratio of the Enrollment rate (%) of Trinidad and Tobago in 2001 to that in 2002?
Make the answer very short. 1.03. What is the ratio of the Enrollment rate (%) of Pacific island small states in 2001 to that in 2003?
Ensure brevity in your answer.  0.98. What is the ratio of the Enrollment rate (%) of Moldova in 2001 to that in 2003?
Keep it short and to the point. 0.98. What is the ratio of the Enrollment rate (%) of Slovenia in 2001 to that in 2003?
Your answer should be very brief. 0.99. What is the ratio of the Enrollment rate (%) of Trinidad and Tobago in 2001 to that in 2003?
Your answer should be compact. 1.02. What is the ratio of the Enrollment rate (%) of Pacific island small states in 2001 to that in 2004?
Provide a short and direct response. 0.98. What is the ratio of the Enrollment rate (%) in Moldova in 2001 to that in 2004?
Offer a very short reply. 0.98. What is the ratio of the Enrollment rate (%) in Slovenia in 2001 to that in 2004?
Your answer should be compact. 0.97. What is the ratio of the Enrollment rate (%) in Trinidad and Tobago in 2001 to that in 2004?
Your response must be concise. 1.01. What is the ratio of the Enrollment rate (%) in Pacific island small states in 2001 to that in 2005?
Your answer should be compact. 0.98. What is the ratio of the Enrollment rate (%) of Moldova in 2001 to that in 2005?
Your answer should be very brief. 1.01. What is the ratio of the Enrollment rate (%) of Slovenia in 2001 to that in 2005?
Provide a short and direct response. 0.98. What is the ratio of the Enrollment rate (%) in Trinidad and Tobago in 2001 to that in 2005?
Give a very brief answer. 1.05. What is the ratio of the Enrollment rate (%) of Pacific island small states in 2001 to that in 2007?
Your answer should be very brief. 0.97. What is the ratio of the Enrollment rate (%) in Moldova in 2001 to that in 2007?
Provide a short and direct response. 1.05. What is the ratio of the Enrollment rate (%) of Slovenia in 2001 to that in 2007?
Offer a terse response. 0.98. What is the ratio of the Enrollment rate (%) in Trinidad and Tobago in 2001 to that in 2007?
Your response must be concise. 1.02. What is the ratio of the Enrollment rate (%) of Pacific island small states in 2001 to that in 2008?
Keep it short and to the point. 0.94. What is the ratio of the Enrollment rate (%) in Moldova in 2001 to that in 2008?
Ensure brevity in your answer.  1.05. What is the ratio of the Enrollment rate (%) in Slovenia in 2001 to that in 2008?
Provide a succinct answer. 0.98. What is the ratio of the Enrollment rate (%) in Trinidad and Tobago in 2001 to that in 2008?
Provide a short and direct response. 1. What is the ratio of the Enrollment rate (%) of Moldova in 2002 to that in 2003?
Offer a terse response. 0.99. What is the ratio of the Enrollment rate (%) in Slovenia in 2002 to that in 2003?
Offer a terse response. 0.99. What is the ratio of the Enrollment rate (%) in Moldova in 2002 to that in 2004?
Offer a terse response. 0.99. What is the ratio of the Enrollment rate (%) of Slovenia in 2002 to that in 2004?
Your response must be concise. 0.97. What is the ratio of the Enrollment rate (%) of Trinidad and Tobago in 2002 to that in 2004?
Offer a very short reply. 0.99. What is the ratio of the Enrollment rate (%) in Moldova in 2002 to that in 2005?
Your answer should be compact. 1.03. What is the ratio of the Enrollment rate (%) in Slovenia in 2002 to that in 2005?
Your answer should be very brief. 0.98. What is the ratio of the Enrollment rate (%) in Trinidad and Tobago in 2002 to that in 2005?
Provide a short and direct response. 1.02. What is the ratio of the Enrollment rate (%) in Pacific island small states in 2002 to that in 2007?
Provide a succinct answer. 0.98. What is the ratio of the Enrollment rate (%) of Moldova in 2002 to that in 2007?
Make the answer very short. 1.07. What is the ratio of the Enrollment rate (%) of Slovenia in 2002 to that in 2007?
Your answer should be very brief. 0.99. What is the ratio of the Enrollment rate (%) in Trinidad and Tobago in 2002 to that in 2007?
Your answer should be very brief. 0.99. What is the ratio of the Enrollment rate (%) of Pacific island small states in 2002 to that in 2008?
Your answer should be compact. 0.96. What is the ratio of the Enrollment rate (%) of Moldova in 2002 to that in 2008?
Provide a succinct answer. 1.06. What is the ratio of the Enrollment rate (%) in Slovenia in 2002 to that in 2008?
Keep it short and to the point. 0.99. What is the ratio of the Enrollment rate (%) in Trinidad and Tobago in 2002 to that in 2008?
Keep it short and to the point. 0.98. What is the ratio of the Enrollment rate (%) of Slovenia in 2003 to that in 2004?
Your answer should be very brief. 0.98. What is the ratio of the Enrollment rate (%) of Moldova in 2003 to that in 2005?
Offer a very short reply. 1.03. What is the ratio of the Enrollment rate (%) in Trinidad and Tobago in 2003 to that in 2005?
Your answer should be compact. 1.02. What is the ratio of the Enrollment rate (%) of Pacific island small states in 2003 to that in 2007?
Offer a very short reply. 0.99. What is the ratio of the Enrollment rate (%) of Moldova in 2003 to that in 2007?
Provide a succinct answer. 1.07. What is the ratio of the Enrollment rate (%) of Slovenia in 2003 to that in 2007?
Offer a terse response. 1. What is the ratio of the Enrollment rate (%) in Pacific island small states in 2003 to that in 2008?
Make the answer very short. 0.96. What is the ratio of the Enrollment rate (%) of Moldova in 2003 to that in 2008?
Give a very brief answer. 1.07. What is the ratio of the Enrollment rate (%) in Trinidad and Tobago in 2003 to that in 2008?
Ensure brevity in your answer.  0.98. What is the ratio of the Enrollment rate (%) of Pacific island small states in 2004 to that in 2005?
Provide a short and direct response. 0.99. What is the ratio of the Enrollment rate (%) of Moldova in 2004 to that in 2005?
Provide a short and direct response. 1.03. What is the ratio of the Enrollment rate (%) of Slovenia in 2004 to that in 2005?
Provide a short and direct response. 1.01. What is the ratio of the Enrollment rate (%) of Trinidad and Tobago in 2004 to that in 2005?
Provide a short and direct response. 1.03. What is the ratio of the Enrollment rate (%) of Pacific island small states in 2004 to that in 2007?
Give a very brief answer. 0.99. What is the ratio of the Enrollment rate (%) of Moldova in 2004 to that in 2007?
Keep it short and to the point. 1.08. What is the ratio of the Enrollment rate (%) in Slovenia in 2004 to that in 2007?
Provide a short and direct response. 1.02. What is the ratio of the Enrollment rate (%) of Pacific island small states in 2004 to that in 2008?
Give a very brief answer. 0.96. What is the ratio of the Enrollment rate (%) in Moldova in 2004 to that in 2008?
Offer a very short reply. 1.07. What is the ratio of the Enrollment rate (%) in Slovenia in 2004 to that in 2008?
Make the answer very short. 1.01. What is the ratio of the Enrollment rate (%) of Trinidad and Tobago in 2004 to that in 2008?
Give a very brief answer. 0.99. What is the ratio of the Enrollment rate (%) in Pacific island small states in 2005 to that in 2007?
Offer a terse response. 0.99. What is the ratio of the Enrollment rate (%) in Slovenia in 2005 to that in 2007?
Provide a succinct answer. 1.01. What is the ratio of the Enrollment rate (%) in Pacific island small states in 2005 to that in 2008?
Offer a very short reply. 0.97. What is the ratio of the Enrollment rate (%) in Moldova in 2005 to that in 2008?
Make the answer very short. 1.04. What is the ratio of the Enrollment rate (%) of Trinidad and Tobago in 2005 to that in 2008?
Make the answer very short. 0.96. What is the ratio of the Enrollment rate (%) in Pacific island small states in 2007 to that in 2008?
Give a very brief answer. 0.97. What is the ratio of the Enrollment rate (%) of Slovenia in 2007 to that in 2008?
Give a very brief answer. 1. What is the difference between the highest and the second highest Enrollment rate (%) of Pacific island small states?
Provide a short and direct response. 2.75. What is the difference between the highest and the second highest Enrollment rate (%) of Moldova?
Provide a succinct answer. 0.28. What is the difference between the highest and the second highest Enrollment rate (%) of Slovenia?
Your answer should be compact. 0.8. What is the difference between the highest and the second highest Enrollment rate (%) in Trinidad and Tobago?
Ensure brevity in your answer.  0.58. What is the difference between the highest and the lowest Enrollment rate (%) in Pacific island small states?
Your response must be concise. 8.56. What is the difference between the highest and the lowest Enrollment rate (%) in Moldova?
Make the answer very short. 6.82. What is the difference between the highest and the lowest Enrollment rate (%) of Slovenia?
Ensure brevity in your answer.  3.13. What is the difference between the highest and the lowest Enrollment rate (%) in Trinidad and Tobago?
Make the answer very short. 5.01. 